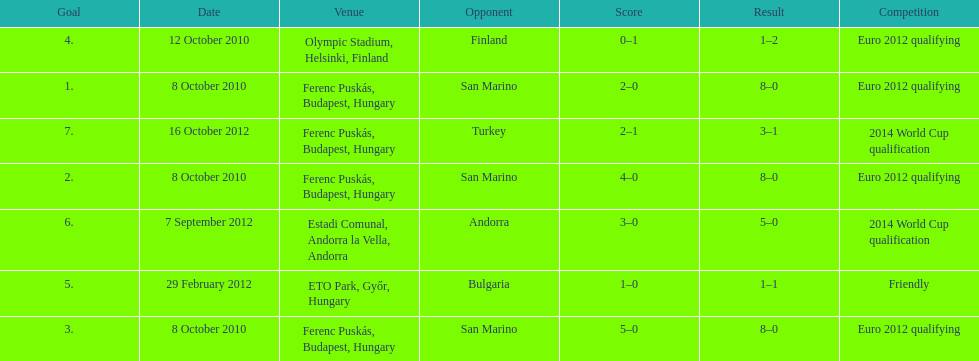Szalai scored all but one of his international goals in either euro 2012 qualifying or what other level of play? 2014 World Cup qualification. 